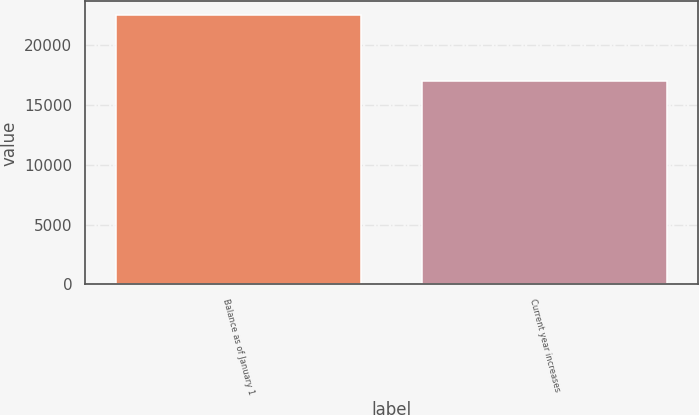Convert chart to OTSL. <chart><loc_0><loc_0><loc_500><loc_500><bar_chart><fcel>Balance as of January 1<fcel>Current year increases<nl><fcel>22505<fcel>17008<nl></chart> 